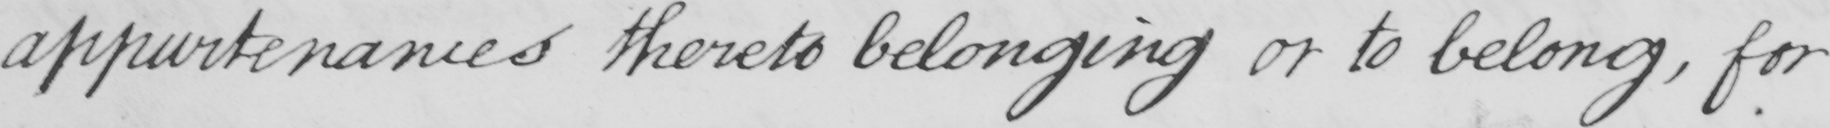Can you read and transcribe this handwriting? appurtenances thereto belonging or to belong , for 